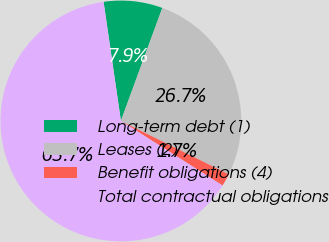Convert chart to OTSL. <chart><loc_0><loc_0><loc_500><loc_500><pie_chart><fcel>Long-term debt (1)<fcel>Leases (2)<fcel>Benefit obligations (4)<fcel>Total contractual obligations<nl><fcel>7.89%<fcel>26.72%<fcel>1.7%<fcel>63.69%<nl></chart> 